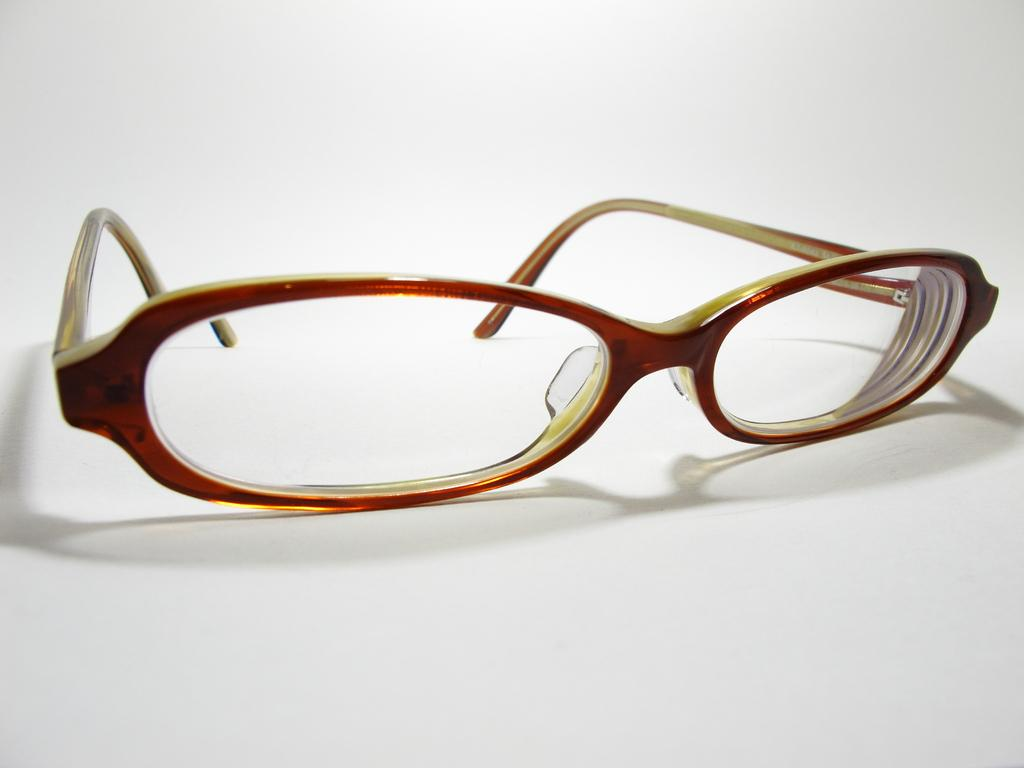What object is located in the middle of the image? There are spectacles in the middle of the image. What can be said about the background of the image? The background of the image is white. What type of competition is taking place in the image? There is no competition present in the image; it features only spectacles in the middle of a white background. What reason can be given for the presence of the spectacles in the image? There is no specific reason given for the presence of the spectacles in the image; they are simply the main subject. 